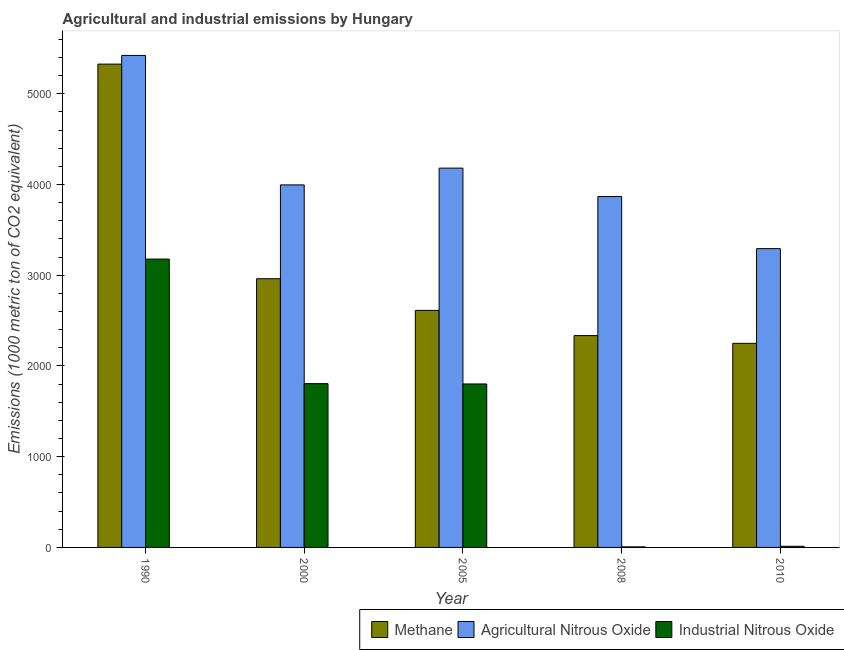How many different coloured bars are there?
Your response must be concise. 3. Are the number of bars per tick equal to the number of legend labels?
Make the answer very short. Yes. Are the number of bars on each tick of the X-axis equal?
Your answer should be very brief. Yes. What is the label of the 3rd group of bars from the left?
Make the answer very short. 2005. In how many cases, is the number of bars for a given year not equal to the number of legend labels?
Provide a short and direct response. 0. What is the amount of industrial nitrous oxide emissions in 2005?
Make the answer very short. 1802. Across all years, what is the maximum amount of methane emissions?
Provide a short and direct response. 5327.6. What is the total amount of methane emissions in the graph?
Offer a terse response. 1.55e+04. What is the difference between the amount of agricultural nitrous oxide emissions in 2000 and that in 2005?
Ensure brevity in your answer.  -184.9. What is the difference between the amount of industrial nitrous oxide emissions in 2000 and the amount of agricultural nitrous oxide emissions in 2010?
Offer a very short reply. 1792.9. What is the average amount of methane emissions per year?
Your answer should be compact. 3097.54. In the year 2008, what is the difference between the amount of industrial nitrous oxide emissions and amount of agricultural nitrous oxide emissions?
Your answer should be compact. 0. In how many years, is the amount of agricultural nitrous oxide emissions greater than 600 metric ton?
Your answer should be very brief. 5. What is the ratio of the amount of industrial nitrous oxide emissions in 2000 to that in 2010?
Keep it short and to the point. 144.43. Is the difference between the amount of industrial nitrous oxide emissions in 2005 and 2008 greater than the difference between the amount of methane emissions in 2005 and 2008?
Offer a very short reply. No. What is the difference between the highest and the second highest amount of methane emissions?
Your answer should be very brief. 2365.7. What is the difference between the highest and the lowest amount of methane emissions?
Provide a short and direct response. 3077.6. What does the 1st bar from the left in 2000 represents?
Your answer should be compact. Methane. What does the 2nd bar from the right in 1990 represents?
Keep it short and to the point. Agricultural Nitrous Oxide. Is it the case that in every year, the sum of the amount of methane emissions and amount of agricultural nitrous oxide emissions is greater than the amount of industrial nitrous oxide emissions?
Give a very brief answer. Yes. How many bars are there?
Your response must be concise. 15. Are all the bars in the graph horizontal?
Keep it short and to the point. No. What is the difference between two consecutive major ticks on the Y-axis?
Your response must be concise. 1000. Does the graph contain grids?
Give a very brief answer. No. Where does the legend appear in the graph?
Your answer should be compact. Bottom right. What is the title of the graph?
Provide a short and direct response. Agricultural and industrial emissions by Hungary. What is the label or title of the X-axis?
Give a very brief answer. Year. What is the label or title of the Y-axis?
Offer a terse response. Emissions (1000 metric ton of CO2 equivalent). What is the Emissions (1000 metric ton of CO2 equivalent) of Methane in 1990?
Your response must be concise. 5327.6. What is the Emissions (1000 metric ton of CO2 equivalent) in Agricultural Nitrous Oxide in 1990?
Offer a terse response. 5423.5. What is the Emissions (1000 metric ton of CO2 equivalent) of Industrial Nitrous Oxide in 1990?
Offer a very short reply. 3178.6. What is the Emissions (1000 metric ton of CO2 equivalent) of Methane in 2000?
Keep it short and to the point. 2961.9. What is the Emissions (1000 metric ton of CO2 equivalent) of Agricultural Nitrous Oxide in 2000?
Provide a short and direct response. 3996.3. What is the Emissions (1000 metric ton of CO2 equivalent) in Industrial Nitrous Oxide in 2000?
Provide a succinct answer. 1805.4. What is the Emissions (1000 metric ton of CO2 equivalent) of Methane in 2005?
Your answer should be very brief. 2613. What is the Emissions (1000 metric ton of CO2 equivalent) of Agricultural Nitrous Oxide in 2005?
Your answer should be very brief. 4181.2. What is the Emissions (1000 metric ton of CO2 equivalent) in Industrial Nitrous Oxide in 2005?
Provide a succinct answer. 1802. What is the Emissions (1000 metric ton of CO2 equivalent) of Methane in 2008?
Your answer should be compact. 2335.2. What is the Emissions (1000 metric ton of CO2 equivalent) in Agricultural Nitrous Oxide in 2008?
Give a very brief answer. 3868. What is the Emissions (1000 metric ton of CO2 equivalent) of Methane in 2010?
Your answer should be very brief. 2250. What is the Emissions (1000 metric ton of CO2 equivalent) in Agricultural Nitrous Oxide in 2010?
Your answer should be very brief. 3293.7. What is the Emissions (1000 metric ton of CO2 equivalent) of Industrial Nitrous Oxide in 2010?
Your answer should be very brief. 12.5. Across all years, what is the maximum Emissions (1000 metric ton of CO2 equivalent) of Methane?
Your answer should be compact. 5327.6. Across all years, what is the maximum Emissions (1000 metric ton of CO2 equivalent) of Agricultural Nitrous Oxide?
Your answer should be very brief. 5423.5. Across all years, what is the maximum Emissions (1000 metric ton of CO2 equivalent) of Industrial Nitrous Oxide?
Ensure brevity in your answer.  3178.6. Across all years, what is the minimum Emissions (1000 metric ton of CO2 equivalent) in Methane?
Provide a short and direct response. 2250. Across all years, what is the minimum Emissions (1000 metric ton of CO2 equivalent) in Agricultural Nitrous Oxide?
Provide a succinct answer. 3293.7. Across all years, what is the minimum Emissions (1000 metric ton of CO2 equivalent) in Industrial Nitrous Oxide?
Your response must be concise. 6. What is the total Emissions (1000 metric ton of CO2 equivalent) of Methane in the graph?
Keep it short and to the point. 1.55e+04. What is the total Emissions (1000 metric ton of CO2 equivalent) of Agricultural Nitrous Oxide in the graph?
Ensure brevity in your answer.  2.08e+04. What is the total Emissions (1000 metric ton of CO2 equivalent) of Industrial Nitrous Oxide in the graph?
Your answer should be very brief. 6804.5. What is the difference between the Emissions (1000 metric ton of CO2 equivalent) in Methane in 1990 and that in 2000?
Your answer should be compact. 2365.7. What is the difference between the Emissions (1000 metric ton of CO2 equivalent) in Agricultural Nitrous Oxide in 1990 and that in 2000?
Ensure brevity in your answer.  1427.2. What is the difference between the Emissions (1000 metric ton of CO2 equivalent) of Industrial Nitrous Oxide in 1990 and that in 2000?
Offer a very short reply. 1373.2. What is the difference between the Emissions (1000 metric ton of CO2 equivalent) of Methane in 1990 and that in 2005?
Your response must be concise. 2714.6. What is the difference between the Emissions (1000 metric ton of CO2 equivalent) in Agricultural Nitrous Oxide in 1990 and that in 2005?
Ensure brevity in your answer.  1242.3. What is the difference between the Emissions (1000 metric ton of CO2 equivalent) of Industrial Nitrous Oxide in 1990 and that in 2005?
Offer a terse response. 1376.6. What is the difference between the Emissions (1000 metric ton of CO2 equivalent) in Methane in 1990 and that in 2008?
Give a very brief answer. 2992.4. What is the difference between the Emissions (1000 metric ton of CO2 equivalent) in Agricultural Nitrous Oxide in 1990 and that in 2008?
Offer a terse response. 1555.5. What is the difference between the Emissions (1000 metric ton of CO2 equivalent) of Industrial Nitrous Oxide in 1990 and that in 2008?
Ensure brevity in your answer.  3172.6. What is the difference between the Emissions (1000 metric ton of CO2 equivalent) of Methane in 1990 and that in 2010?
Provide a succinct answer. 3077.6. What is the difference between the Emissions (1000 metric ton of CO2 equivalent) of Agricultural Nitrous Oxide in 1990 and that in 2010?
Your answer should be compact. 2129.8. What is the difference between the Emissions (1000 metric ton of CO2 equivalent) in Industrial Nitrous Oxide in 1990 and that in 2010?
Your answer should be very brief. 3166.1. What is the difference between the Emissions (1000 metric ton of CO2 equivalent) of Methane in 2000 and that in 2005?
Give a very brief answer. 348.9. What is the difference between the Emissions (1000 metric ton of CO2 equivalent) in Agricultural Nitrous Oxide in 2000 and that in 2005?
Your response must be concise. -184.9. What is the difference between the Emissions (1000 metric ton of CO2 equivalent) of Methane in 2000 and that in 2008?
Make the answer very short. 626.7. What is the difference between the Emissions (1000 metric ton of CO2 equivalent) in Agricultural Nitrous Oxide in 2000 and that in 2008?
Make the answer very short. 128.3. What is the difference between the Emissions (1000 metric ton of CO2 equivalent) of Industrial Nitrous Oxide in 2000 and that in 2008?
Your response must be concise. 1799.4. What is the difference between the Emissions (1000 metric ton of CO2 equivalent) in Methane in 2000 and that in 2010?
Make the answer very short. 711.9. What is the difference between the Emissions (1000 metric ton of CO2 equivalent) of Agricultural Nitrous Oxide in 2000 and that in 2010?
Make the answer very short. 702.6. What is the difference between the Emissions (1000 metric ton of CO2 equivalent) of Industrial Nitrous Oxide in 2000 and that in 2010?
Your response must be concise. 1792.9. What is the difference between the Emissions (1000 metric ton of CO2 equivalent) of Methane in 2005 and that in 2008?
Your answer should be compact. 277.8. What is the difference between the Emissions (1000 metric ton of CO2 equivalent) in Agricultural Nitrous Oxide in 2005 and that in 2008?
Offer a terse response. 313.2. What is the difference between the Emissions (1000 metric ton of CO2 equivalent) in Industrial Nitrous Oxide in 2005 and that in 2008?
Keep it short and to the point. 1796. What is the difference between the Emissions (1000 metric ton of CO2 equivalent) of Methane in 2005 and that in 2010?
Offer a terse response. 363. What is the difference between the Emissions (1000 metric ton of CO2 equivalent) in Agricultural Nitrous Oxide in 2005 and that in 2010?
Your answer should be very brief. 887.5. What is the difference between the Emissions (1000 metric ton of CO2 equivalent) in Industrial Nitrous Oxide in 2005 and that in 2010?
Provide a succinct answer. 1789.5. What is the difference between the Emissions (1000 metric ton of CO2 equivalent) in Methane in 2008 and that in 2010?
Provide a succinct answer. 85.2. What is the difference between the Emissions (1000 metric ton of CO2 equivalent) of Agricultural Nitrous Oxide in 2008 and that in 2010?
Provide a succinct answer. 574.3. What is the difference between the Emissions (1000 metric ton of CO2 equivalent) of Industrial Nitrous Oxide in 2008 and that in 2010?
Give a very brief answer. -6.5. What is the difference between the Emissions (1000 metric ton of CO2 equivalent) in Methane in 1990 and the Emissions (1000 metric ton of CO2 equivalent) in Agricultural Nitrous Oxide in 2000?
Keep it short and to the point. 1331.3. What is the difference between the Emissions (1000 metric ton of CO2 equivalent) in Methane in 1990 and the Emissions (1000 metric ton of CO2 equivalent) in Industrial Nitrous Oxide in 2000?
Your response must be concise. 3522.2. What is the difference between the Emissions (1000 metric ton of CO2 equivalent) of Agricultural Nitrous Oxide in 1990 and the Emissions (1000 metric ton of CO2 equivalent) of Industrial Nitrous Oxide in 2000?
Provide a succinct answer. 3618.1. What is the difference between the Emissions (1000 metric ton of CO2 equivalent) of Methane in 1990 and the Emissions (1000 metric ton of CO2 equivalent) of Agricultural Nitrous Oxide in 2005?
Your answer should be compact. 1146.4. What is the difference between the Emissions (1000 metric ton of CO2 equivalent) in Methane in 1990 and the Emissions (1000 metric ton of CO2 equivalent) in Industrial Nitrous Oxide in 2005?
Give a very brief answer. 3525.6. What is the difference between the Emissions (1000 metric ton of CO2 equivalent) of Agricultural Nitrous Oxide in 1990 and the Emissions (1000 metric ton of CO2 equivalent) of Industrial Nitrous Oxide in 2005?
Your answer should be compact. 3621.5. What is the difference between the Emissions (1000 metric ton of CO2 equivalent) in Methane in 1990 and the Emissions (1000 metric ton of CO2 equivalent) in Agricultural Nitrous Oxide in 2008?
Your response must be concise. 1459.6. What is the difference between the Emissions (1000 metric ton of CO2 equivalent) of Methane in 1990 and the Emissions (1000 metric ton of CO2 equivalent) of Industrial Nitrous Oxide in 2008?
Your response must be concise. 5321.6. What is the difference between the Emissions (1000 metric ton of CO2 equivalent) in Agricultural Nitrous Oxide in 1990 and the Emissions (1000 metric ton of CO2 equivalent) in Industrial Nitrous Oxide in 2008?
Make the answer very short. 5417.5. What is the difference between the Emissions (1000 metric ton of CO2 equivalent) in Methane in 1990 and the Emissions (1000 metric ton of CO2 equivalent) in Agricultural Nitrous Oxide in 2010?
Give a very brief answer. 2033.9. What is the difference between the Emissions (1000 metric ton of CO2 equivalent) of Methane in 1990 and the Emissions (1000 metric ton of CO2 equivalent) of Industrial Nitrous Oxide in 2010?
Offer a terse response. 5315.1. What is the difference between the Emissions (1000 metric ton of CO2 equivalent) in Agricultural Nitrous Oxide in 1990 and the Emissions (1000 metric ton of CO2 equivalent) in Industrial Nitrous Oxide in 2010?
Offer a terse response. 5411. What is the difference between the Emissions (1000 metric ton of CO2 equivalent) of Methane in 2000 and the Emissions (1000 metric ton of CO2 equivalent) of Agricultural Nitrous Oxide in 2005?
Your answer should be very brief. -1219.3. What is the difference between the Emissions (1000 metric ton of CO2 equivalent) in Methane in 2000 and the Emissions (1000 metric ton of CO2 equivalent) in Industrial Nitrous Oxide in 2005?
Your response must be concise. 1159.9. What is the difference between the Emissions (1000 metric ton of CO2 equivalent) of Agricultural Nitrous Oxide in 2000 and the Emissions (1000 metric ton of CO2 equivalent) of Industrial Nitrous Oxide in 2005?
Your answer should be compact. 2194.3. What is the difference between the Emissions (1000 metric ton of CO2 equivalent) of Methane in 2000 and the Emissions (1000 metric ton of CO2 equivalent) of Agricultural Nitrous Oxide in 2008?
Offer a very short reply. -906.1. What is the difference between the Emissions (1000 metric ton of CO2 equivalent) in Methane in 2000 and the Emissions (1000 metric ton of CO2 equivalent) in Industrial Nitrous Oxide in 2008?
Offer a terse response. 2955.9. What is the difference between the Emissions (1000 metric ton of CO2 equivalent) in Agricultural Nitrous Oxide in 2000 and the Emissions (1000 metric ton of CO2 equivalent) in Industrial Nitrous Oxide in 2008?
Ensure brevity in your answer.  3990.3. What is the difference between the Emissions (1000 metric ton of CO2 equivalent) in Methane in 2000 and the Emissions (1000 metric ton of CO2 equivalent) in Agricultural Nitrous Oxide in 2010?
Ensure brevity in your answer.  -331.8. What is the difference between the Emissions (1000 metric ton of CO2 equivalent) in Methane in 2000 and the Emissions (1000 metric ton of CO2 equivalent) in Industrial Nitrous Oxide in 2010?
Your response must be concise. 2949.4. What is the difference between the Emissions (1000 metric ton of CO2 equivalent) in Agricultural Nitrous Oxide in 2000 and the Emissions (1000 metric ton of CO2 equivalent) in Industrial Nitrous Oxide in 2010?
Provide a succinct answer. 3983.8. What is the difference between the Emissions (1000 metric ton of CO2 equivalent) in Methane in 2005 and the Emissions (1000 metric ton of CO2 equivalent) in Agricultural Nitrous Oxide in 2008?
Give a very brief answer. -1255. What is the difference between the Emissions (1000 metric ton of CO2 equivalent) in Methane in 2005 and the Emissions (1000 metric ton of CO2 equivalent) in Industrial Nitrous Oxide in 2008?
Your answer should be very brief. 2607. What is the difference between the Emissions (1000 metric ton of CO2 equivalent) in Agricultural Nitrous Oxide in 2005 and the Emissions (1000 metric ton of CO2 equivalent) in Industrial Nitrous Oxide in 2008?
Provide a succinct answer. 4175.2. What is the difference between the Emissions (1000 metric ton of CO2 equivalent) in Methane in 2005 and the Emissions (1000 metric ton of CO2 equivalent) in Agricultural Nitrous Oxide in 2010?
Make the answer very short. -680.7. What is the difference between the Emissions (1000 metric ton of CO2 equivalent) of Methane in 2005 and the Emissions (1000 metric ton of CO2 equivalent) of Industrial Nitrous Oxide in 2010?
Your response must be concise. 2600.5. What is the difference between the Emissions (1000 metric ton of CO2 equivalent) in Agricultural Nitrous Oxide in 2005 and the Emissions (1000 metric ton of CO2 equivalent) in Industrial Nitrous Oxide in 2010?
Give a very brief answer. 4168.7. What is the difference between the Emissions (1000 metric ton of CO2 equivalent) in Methane in 2008 and the Emissions (1000 metric ton of CO2 equivalent) in Agricultural Nitrous Oxide in 2010?
Make the answer very short. -958.5. What is the difference between the Emissions (1000 metric ton of CO2 equivalent) in Methane in 2008 and the Emissions (1000 metric ton of CO2 equivalent) in Industrial Nitrous Oxide in 2010?
Offer a very short reply. 2322.7. What is the difference between the Emissions (1000 metric ton of CO2 equivalent) in Agricultural Nitrous Oxide in 2008 and the Emissions (1000 metric ton of CO2 equivalent) in Industrial Nitrous Oxide in 2010?
Give a very brief answer. 3855.5. What is the average Emissions (1000 metric ton of CO2 equivalent) of Methane per year?
Offer a very short reply. 3097.54. What is the average Emissions (1000 metric ton of CO2 equivalent) of Agricultural Nitrous Oxide per year?
Give a very brief answer. 4152.54. What is the average Emissions (1000 metric ton of CO2 equivalent) of Industrial Nitrous Oxide per year?
Provide a succinct answer. 1360.9. In the year 1990, what is the difference between the Emissions (1000 metric ton of CO2 equivalent) of Methane and Emissions (1000 metric ton of CO2 equivalent) of Agricultural Nitrous Oxide?
Your answer should be compact. -95.9. In the year 1990, what is the difference between the Emissions (1000 metric ton of CO2 equivalent) of Methane and Emissions (1000 metric ton of CO2 equivalent) of Industrial Nitrous Oxide?
Your answer should be very brief. 2149. In the year 1990, what is the difference between the Emissions (1000 metric ton of CO2 equivalent) in Agricultural Nitrous Oxide and Emissions (1000 metric ton of CO2 equivalent) in Industrial Nitrous Oxide?
Your answer should be compact. 2244.9. In the year 2000, what is the difference between the Emissions (1000 metric ton of CO2 equivalent) of Methane and Emissions (1000 metric ton of CO2 equivalent) of Agricultural Nitrous Oxide?
Ensure brevity in your answer.  -1034.4. In the year 2000, what is the difference between the Emissions (1000 metric ton of CO2 equivalent) of Methane and Emissions (1000 metric ton of CO2 equivalent) of Industrial Nitrous Oxide?
Provide a short and direct response. 1156.5. In the year 2000, what is the difference between the Emissions (1000 metric ton of CO2 equivalent) of Agricultural Nitrous Oxide and Emissions (1000 metric ton of CO2 equivalent) of Industrial Nitrous Oxide?
Provide a short and direct response. 2190.9. In the year 2005, what is the difference between the Emissions (1000 metric ton of CO2 equivalent) in Methane and Emissions (1000 metric ton of CO2 equivalent) in Agricultural Nitrous Oxide?
Offer a very short reply. -1568.2. In the year 2005, what is the difference between the Emissions (1000 metric ton of CO2 equivalent) in Methane and Emissions (1000 metric ton of CO2 equivalent) in Industrial Nitrous Oxide?
Your answer should be compact. 811. In the year 2005, what is the difference between the Emissions (1000 metric ton of CO2 equivalent) of Agricultural Nitrous Oxide and Emissions (1000 metric ton of CO2 equivalent) of Industrial Nitrous Oxide?
Keep it short and to the point. 2379.2. In the year 2008, what is the difference between the Emissions (1000 metric ton of CO2 equivalent) in Methane and Emissions (1000 metric ton of CO2 equivalent) in Agricultural Nitrous Oxide?
Keep it short and to the point. -1532.8. In the year 2008, what is the difference between the Emissions (1000 metric ton of CO2 equivalent) of Methane and Emissions (1000 metric ton of CO2 equivalent) of Industrial Nitrous Oxide?
Keep it short and to the point. 2329.2. In the year 2008, what is the difference between the Emissions (1000 metric ton of CO2 equivalent) in Agricultural Nitrous Oxide and Emissions (1000 metric ton of CO2 equivalent) in Industrial Nitrous Oxide?
Ensure brevity in your answer.  3862. In the year 2010, what is the difference between the Emissions (1000 metric ton of CO2 equivalent) of Methane and Emissions (1000 metric ton of CO2 equivalent) of Agricultural Nitrous Oxide?
Offer a terse response. -1043.7. In the year 2010, what is the difference between the Emissions (1000 metric ton of CO2 equivalent) in Methane and Emissions (1000 metric ton of CO2 equivalent) in Industrial Nitrous Oxide?
Make the answer very short. 2237.5. In the year 2010, what is the difference between the Emissions (1000 metric ton of CO2 equivalent) in Agricultural Nitrous Oxide and Emissions (1000 metric ton of CO2 equivalent) in Industrial Nitrous Oxide?
Your answer should be very brief. 3281.2. What is the ratio of the Emissions (1000 metric ton of CO2 equivalent) of Methane in 1990 to that in 2000?
Keep it short and to the point. 1.8. What is the ratio of the Emissions (1000 metric ton of CO2 equivalent) of Agricultural Nitrous Oxide in 1990 to that in 2000?
Give a very brief answer. 1.36. What is the ratio of the Emissions (1000 metric ton of CO2 equivalent) of Industrial Nitrous Oxide in 1990 to that in 2000?
Your response must be concise. 1.76. What is the ratio of the Emissions (1000 metric ton of CO2 equivalent) of Methane in 1990 to that in 2005?
Give a very brief answer. 2.04. What is the ratio of the Emissions (1000 metric ton of CO2 equivalent) in Agricultural Nitrous Oxide in 1990 to that in 2005?
Provide a short and direct response. 1.3. What is the ratio of the Emissions (1000 metric ton of CO2 equivalent) in Industrial Nitrous Oxide in 1990 to that in 2005?
Your response must be concise. 1.76. What is the ratio of the Emissions (1000 metric ton of CO2 equivalent) in Methane in 1990 to that in 2008?
Provide a short and direct response. 2.28. What is the ratio of the Emissions (1000 metric ton of CO2 equivalent) of Agricultural Nitrous Oxide in 1990 to that in 2008?
Your answer should be very brief. 1.4. What is the ratio of the Emissions (1000 metric ton of CO2 equivalent) of Industrial Nitrous Oxide in 1990 to that in 2008?
Your response must be concise. 529.77. What is the ratio of the Emissions (1000 metric ton of CO2 equivalent) of Methane in 1990 to that in 2010?
Offer a terse response. 2.37. What is the ratio of the Emissions (1000 metric ton of CO2 equivalent) in Agricultural Nitrous Oxide in 1990 to that in 2010?
Provide a succinct answer. 1.65. What is the ratio of the Emissions (1000 metric ton of CO2 equivalent) in Industrial Nitrous Oxide in 1990 to that in 2010?
Your response must be concise. 254.29. What is the ratio of the Emissions (1000 metric ton of CO2 equivalent) in Methane in 2000 to that in 2005?
Provide a succinct answer. 1.13. What is the ratio of the Emissions (1000 metric ton of CO2 equivalent) in Agricultural Nitrous Oxide in 2000 to that in 2005?
Give a very brief answer. 0.96. What is the ratio of the Emissions (1000 metric ton of CO2 equivalent) of Methane in 2000 to that in 2008?
Ensure brevity in your answer.  1.27. What is the ratio of the Emissions (1000 metric ton of CO2 equivalent) in Agricultural Nitrous Oxide in 2000 to that in 2008?
Provide a short and direct response. 1.03. What is the ratio of the Emissions (1000 metric ton of CO2 equivalent) of Industrial Nitrous Oxide in 2000 to that in 2008?
Your answer should be very brief. 300.9. What is the ratio of the Emissions (1000 metric ton of CO2 equivalent) in Methane in 2000 to that in 2010?
Make the answer very short. 1.32. What is the ratio of the Emissions (1000 metric ton of CO2 equivalent) in Agricultural Nitrous Oxide in 2000 to that in 2010?
Your answer should be very brief. 1.21. What is the ratio of the Emissions (1000 metric ton of CO2 equivalent) in Industrial Nitrous Oxide in 2000 to that in 2010?
Make the answer very short. 144.43. What is the ratio of the Emissions (1000 metric ton of CO2 equivalent) in Methane in 2005 to that in 2008?
Give a very brief answer. 1.12. What is the ratio of the Emissions (1000 metric ton of CO2 equivalent) of Agricultural Nitrous Oxide in 2005 to that in 2008?
Give a very brief answer. 1.08. What is the ratio of the Emissions (1000 metric ton of CO2 equivalent) in Industrial Nitrous Oxide in 2005 to that in 2008?
Your answer should be compact. 300.33. What is the ratio of the Emissions (1000 metric ton of CO2 equivalent) in Methane in 2005 to that in 2010?
Provide a succinct answer. 1.16. What is the ratio of the Emissions (1000 metric ton of CO2 equivalent) of Agricultural Nitrous Oxide in 2005 to that in 2010?
Make the answer very short. 1.27. What is the ratio of the Emissions (1000 metric ton of CO2 equivalent) in Industrial Nitrous Oxide in 2005 to that in 2010?
Provide a short and direct response. 144.16. What is the ratio of the Emissions (1000 metric ton of CO2 equivalent) of Methane in 2008 to that in 2010?
Your answer should be compact. 1.04. What is the ratio of the Emissions (1000 metric ton of CO2 equivalent) of Agricultural Nitrous Oxide in 2008 to that in 2010?
Offer a terse response. 1.17. What is the ratio of the Emissions (1000 metric ton of CO2 equivalent) of Industrial Nitrous Oxide in 2008 to that in 2010?
Offer a terse response. 0.48. What is the difference between the highest and the second highest Emissions (1000 metric ton of CO2 equivalent) of Methane?
Offer a very short reply. 2365.7. What is the difference between the highest and the second highest Emissions (1000 metric ton of CO2 equivalent) of Agricultural Nitrous Oxide?
Your response must be concise. 1242.3. What is the difference between the highest and the second highest Emissions (1000 metric ton of CO2 equivalent) in Industrial Nitrous Oxide?
Ensure brevity in your answer.  1373.2. What is the difference between the highest and the lowest Emissions (1000 metric ton of CO2 equivalent) of Methane?
Give a very brief answer. 3077.6. What is the difference between the highest and the lowest Emissions (1000 metric ton of CO2 equivalent) of Agricultural Nitrous Oxide?
Give a very brief answer. 2129.8. What is the difference between the highest and the lowest Emissions (1000 metric ton of CO2 equivalent) of Industrial Nitrous Oxide?
Provide a succinct answer. 3172.6. 